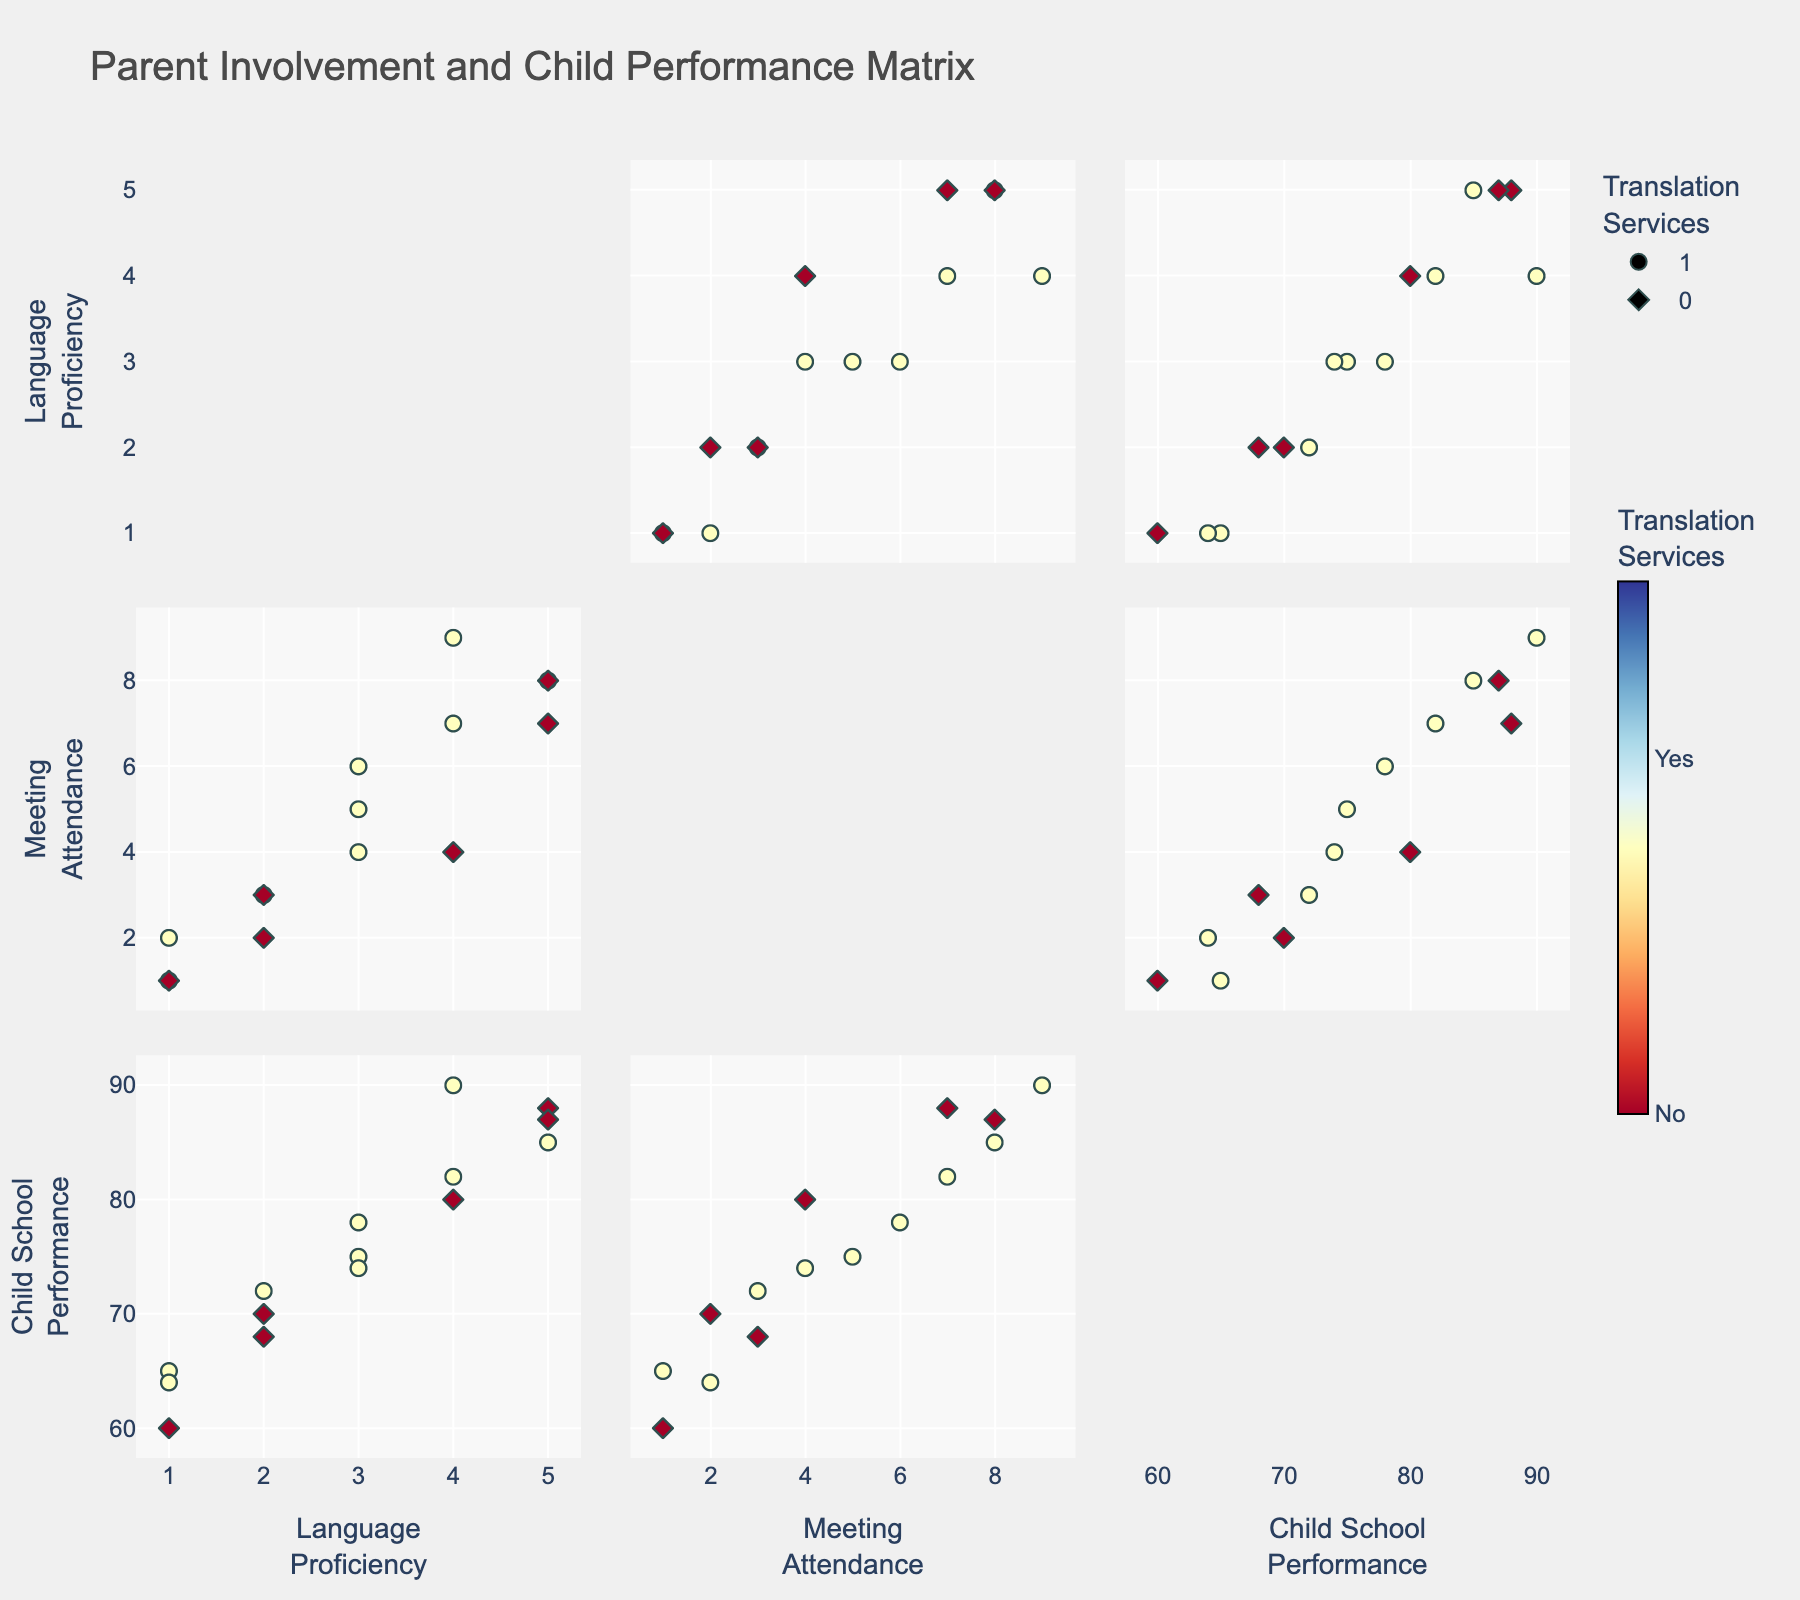How many parents have access to translation services? Look at the color and symbol distinctions in the SPLOM. Parents with access to translation services are indicated by circles. Count the number of circle symbols.
Answer: 8 Which group has higher child school performance on average: parents with or without translation services? First, identify the groups based on the symbols (circles for translation services and diamonds for no translation services). Calculate the average child school performance for each group. For parents with translation services: (85 + 75 + 75 + 80 + 64 + 90 + 82)/8 = 78.38. For parents without translation services: (70 + 80 + 65 + 60 + 68 + 87)/6 = 71.67. Compare the averages.
Answer: Parents with translation services Is there a visible relationship between language proficiency and parent-teacher meeting attendance? Observe the scatter plot axis for Language Proficiency and Parent-Teacher Meeting Attendance. Look for any patterns or trends, such as whether higher language proficiency is associated with more meeting attendance.
Answer: Yes, higher language proficiency tends to correlate with more meeting attendance Between parents with translation services and parents without, which group attends more parent-teacher meetings? Compare the Parent-Teacher Meeting Attendance values for the two groups indicated by circles (translation services) and diamonds (no translation services). On average, parents with translation services attend more meetings.
Answer: Parents with translation services Do parents with higher language proficiency also have higher child school performance? Examine the scatter plot section that correlates Language Proficiency with Child School Performance. Check if higher proficiency scores align with higher performance scores.
Answer: Generally, yes What is the most common range of child school performance for parents without access to translation services? Look at the scatter plot points for Child School Performance colored as diamond symbols. Identify the range where most data points fall.
Answer: 60 to 80 Does any parent with the lowest language proficiency score have a high parent-teacher meeting attendance? Check the data points where the Language Proficiency score is 1. See if any of these points align with high Parent-Teacher Meeting Attendance values.
Answer: No What is the relationship between meeting attendance and child performance for parents with high language proficiency? Focus on the scatter plot points where Language Proficiency is high (4 or 5). Compare the Parent-Teacher Meeting Attendance and Child School Performance values.
Answer: Higher meeting attendance tends to correlate with higher child performance 